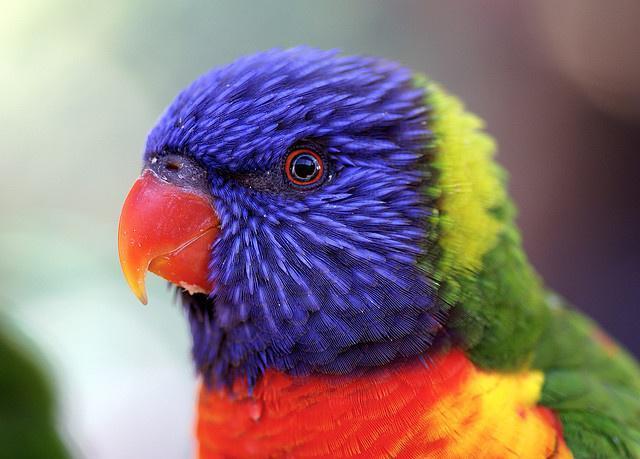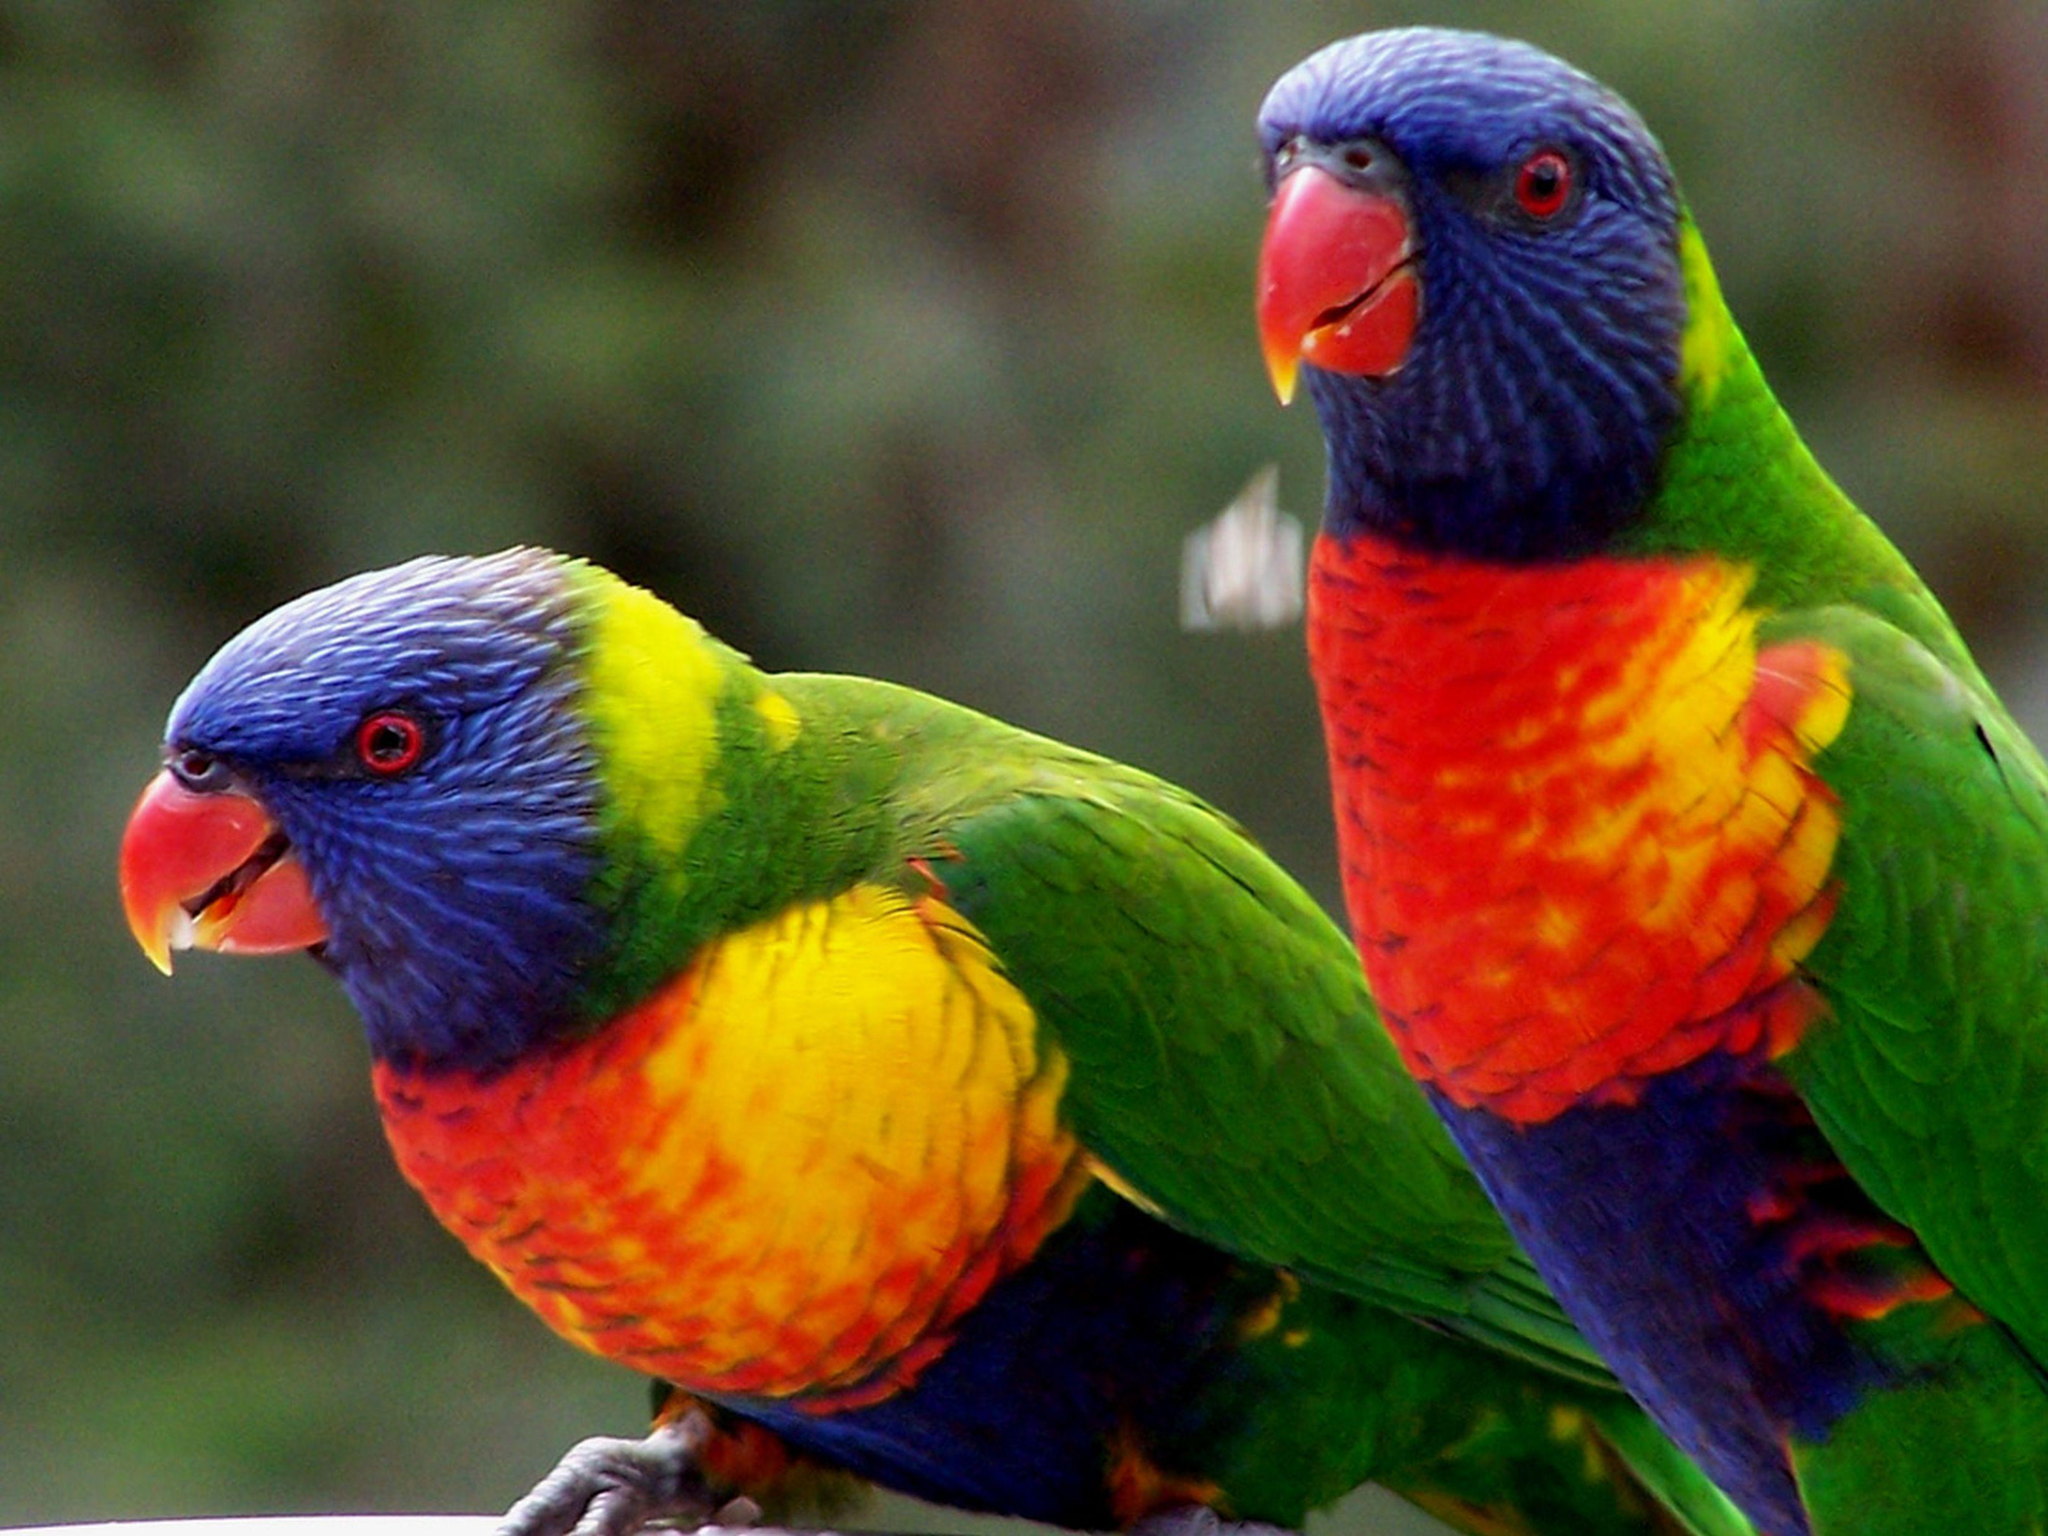The first image is the image on the left, the second image is the image on the right. Assess this claim about the two images: "At least two parrots are facing left.". Correct or not? Answer yes or no. Yes. The first image is the image on the left, the second image is the image on the right. For the images shown, is this caption "The left image includes twice as many parrots as the right image." true? Answer yes or no. No. 